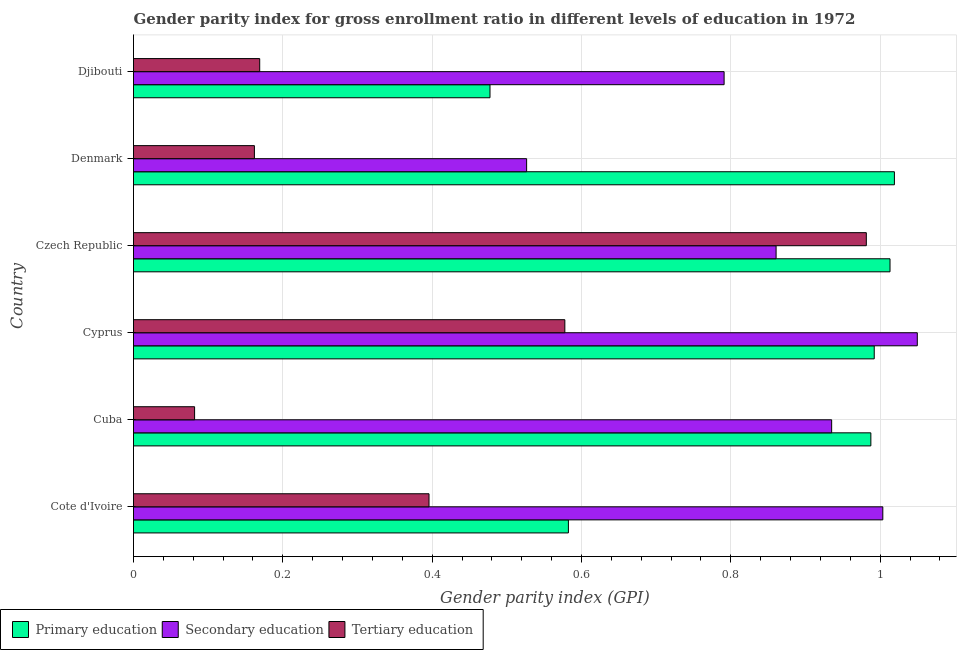How many groups of bars are there?
Your answer should be very brief. 6. Are the number of bars on each tick of the Y-axis equal?
Offer a very short reply. Yes. What is the label of the 4th group of bars from the top?
Your answer should be compact. Cyprus. What is the gender parity index in primary education in Cote d'Ivoire?
Your answer should be compact. 0.58. Across all countries, what is the maximum gender parity index in primary education?
Your answer should be compact. 1.02. Across all countries, what is the minimum gender parity index in secondary education?
Keep it short and to the point. 0.53. In which country was the gender parity index in tertiary education maximum?
Keep it short and to the point. Czech Republic. In which country was the gender parity index in primary education minimum?
Your response must be concise. Djibouti. What is the total gender parity index in primary education in the graph?
Provide a short and direct response. 5.07. What is the difference between the gender parity index in tertiary education in Cyprus and that in Djibouti?
Offer a very short reply. 0.41. What is the difference between the gender parity index in primary education in Cyprus and the gender parity index in secondary education in Cuba?
Keep it short and to the point. 0.06. What is the average gender parity index in secondary education per country?
Provide a succinct answer. 0.86. What is the difference between the gender parity index in secondary education and gender parity index in primary education in Djibouti?
Your response must be concise. 0.31. Is the difference between the gender parity index in primary education in Cyprus and Denmark greater than the difference between the gender parity index in tertiary education in Cyprus and Denmark?
Your answer should be compact. No. What is the difference between the highest and the second highest gender parity index in primary education?
Provide a short and direct response. 0.01. What is the difference between the highest and the lowest gender parity index in primary education?
Your response must be concise. 0.54. Is the sum of the gender parity index in primary education in Czech Republic and Denmark greater than the maximum gender parity index in secondary education across all countries?
Ensure brevity in your answer.  Yes. What does the 2nd bar from the bottom in Djibouti represents?
Offer a very short reply. Secondary education. How many countries are there in the graph?
Keep it short and to the point. 6. What is the difference between two consecutive major ticks on the X-axis?
Provide a short and direct response. 0.2. Does the graph contain grids?
Give a very brief answer. Yes. Where does the legend appear in the graph?
Provide a succinct answer. Bottom left. How are the legend labels stacked?
Give a very brief answer. Horizontal. What is the title of the graph?
Ensure brevity in your answer.  Gender parity index for gross enrollment ratio in different levels of education in 1972. What is the label or title of the X-axis?
Offer a terse response. Gender parity index (GPI). What is the Gender parity index (GPI) in Primary education in Cote d'Ivoire?
Your answer should be compact. 0.58. What is the Gender parity index (GPI) in Secondary education in Cote d'Ivoire?
Give a very brief answer. 1. What is the Gender parity index (GPI) in Tertiary education in Cote d'Ivoire?
Offer a terse response. 0.4. What is the Gender parity index (GPI) in Primary education in Cuba?
Your answer should be very brief. 0.99. What is the Gender parity index (GPI) in Secondary education in Cuba?
Your answer should be very brief. 0.94. What is the Gender parity index (GPI) of Tertiary education in Cuba?
Ensure brevity in your answer.  0.08. What is the Gender parity index (GPI) in Primary education in Cyprus?
Keep it short and to the point. 0.99. What is the Gender parity index (GPI) of Secondary education in Cyprus?
Provide a short and direct response. 1.05. What is the Gender parity index (GPI) of Tertiary education in Cyprus?
Give a very brief answer. 0.58. What is the Gender parity index (GPI) in Primary education in Czech Republic?
Provide a succinct answer. 1.01. What is the Gender parity index (GPI) in Secondary education in Czech Republic?
Give a very brief answer. 0.86. What is the Gender parity index (GPI) of Tertiary education in Czech Republic?
Ensure brevity in your answer.  0.98. What is the Gender parity index (GPI) in Primary education in Denmark?
Your answer should be very brief. 1.02. What is the Gender parity index (GPI) in Secondary education in Denmark?
Provide a short and direct response. 0.53. What is the Gender parity index (GPI) of Tertiary education in Denmark?
Give a very brief answer. 0.16. What is the Gender parity index (GPI) in Primary education in Djibouti?
Your answer should be very brief. 0.48. What is the Gender parity index (GPI) of Secondary education in Djibouti?
Your answer should be very brief. 0.79. What is the Gender parity index (GPI) of Tertiary education in Djibouti?
Your response must be concise. 0.17. Across all countries, what is the maximum Gender parity index (GPI) in Primary education?
Ensure brevity in your answer.  1.02. Across all countries, what is the maximum Gender parity index (GPI) of Secondary education?
Your answer should be very brief. 1.05. Across all countries, what is the maximum Gender parity index (GPI) of Tertiary education?
Keep it short and to the point. 0.98. Across all countries, what is the minimum Gender parity index (GPI) of Primary education?
Provide a short and direct response. 0.48. Across all countries, what is the minimum Gender parity index (GPI) in Secondary education?
Give a very brief answer. 0.53. Across all countries, what is the minimum Gender parity index (GPI) in Tertiary education?
Your answer should be very brief. 0.08. What is the total Gender parity index (GPI) of Primary education in the graph?
Give a very brief answer. 5.07. What is the total Gender parity index (GPI) of Secondary education in the graph?
Keep it short and to the point. 5.17. What is the total Gender parity index (GPI) in Tertiary education in the graph?
Keep it short and to the point. 2.37. What is the difference between the Gender parity index (GPI) of Primary education in Cote d'Ivoire and that in Cuba?
Give a very brief answer. -0.41. What is the difference between the Gender parity index (GPI) in Secondary education in Cote d'Ivoire and that in Cuba?
Give a very brief answer. 0.07. What is the difference between the Gender parity index (GPI) of Tertiary education in Cote d'Ivoire and that in Cuba?
Keep it short and to the point. 0.31. What is the difference between the Gender parity index (GPI) in Primary education in Cote d'Ivoire and that in Cyprus?
Keep it short and to the point. -0.41. What is the difference between the Gender parity index (GPI) in Secondary education in Cote d'Ivoire and that in Cyprus?
Provide a succinct answer. -0.05. What is the difference between the Gender parity index (GPI) of Tertiary education in Cote d'Ivoire and that in Cyprus?
Give a very brief answer. -0.18. What is the difference between the Gender parity index (GPI) in Primary education in Cote d'Ivoire and that in Czech Republic?
Your response must be concise. -0.43. What is the difference between the Gender parity index (GPI) of Secondary education in Cote d'Ivoire and that in Czech Republic?
Keep it short and to the point. 0.14. What is the difference between the Gender parity index (GPI) of Tertiary education in Cote d'Ivoire and that in Czech Republic?
Your answer should be very brief. -0.59. What is the difference between the Gender parity index (GPI) in Primary education in Cote d'Ivoire and that in Denmark?
Provide a short and direct response. -0.44. What is the difference between the Gender parity index (GPI) in Secondary education in Cote d'Ivoire and that in Denmark?
Provide a short and direct response. 0.48. What is the difference between the Gender parity index (GPI) in Tertiary education in Cote d'Ivoire and that in Denmark?
Offer a terse response. 0.23. What is the difference between the Gender parity index (GPI) of Primary education in Cote d'Ivoire and that in Djibouti?
Keep it short and to the point. 0.1. What is the difference between the Gender parity index (GPI) in Secondary education in Cote d'Ivoire and that in Djibouti?
Give a very brief answer. 0.21. What is the difference between the Gender parity index (GPI) in Tertiary education in Cote d'Ivoire and that in Djibouti?
Your response must be concise. 0.23. What is the difference between the Gender parity index (GPI) in Primary education in Cuba and that in Cyprus?
Your answer should be compact. -0. What is the difference between the Gender parity index (GPI) of Secondary education in Cuba and that in Cyprus?
Provide a short and direct response. -0.11. What is the difference between the Gender parity index (GPI) of Tertiary education in Cuba and that in Cyprus?
Provide a succinct answer. -0.5. What is the difference between the Gender parity index (GPI) of Primary education in Cuba and that in Czech Republic?
Keep it short and to the point. -0.03. What is the difference between the Gender parity index (GPI) in Secondary education in Cuba and that in Czech Republic?
Offer a terse response. 0.07. What is the difference between the Gender parity index (GPI) of Tertiary education in Cuba and that in Czech Republic?
Offer a terse response. -0.9. What is the difference between the Gender parity index (GPI) in Primary education in Cuba and that in Denmark?
Your response must be concise. -0.03. What is the difference between the Gender parity index (GPI) in Secondary education in Cuba and that in Denmark?
Your answer should be compact. 0.41. What is the difference between the Gender parity index (GPI) in Tertiary education in Cuba and that in Denmark?
Your answer should be compact. -0.08. What is the difference between the Gender parity index (GPI) of Primary education in Cuba and that in Djibouti?
Make the answer very short. 0.51. What is the difference between the Gender parity index (GPI) in Secondary education in Cuba and that in Djibouti?
Offer a terse response. 0.14. What is the difference between the Gender parity index (GPI) in Tertiary education in Cuba and that in Djibouti?
Provide a succinct answer. -0.09. What is the difference between the Gender parity index (GPI) in Primary education in Cyprus and that in Czech Republic?
Your answer should be very brief. -0.02. What is the difference between the Gender parity index (GPI) in Secondary education in Cyprus and that in Czech Republic?
Offer a terse response. 0.19. What is the difference between the Gender parity index (GPI) of Tertiary education in Cyprus and that in Czech Republic?
Provide a succinct answer. -0.4. What is the difference between the Gender parity index (GPI) of Primary education in Cyprus and that in Denmark?
Offer a very short reply. -0.03. What is the difference between the Gender parity index (GPI) of Secondary education in Cyprus and that in Denmark?
Offer a terse response. 0.52. What is the difference between the Gender parity index (GPI) of Tertiary education in Cyprus and that in Denmark?
Offer a very short reply. 0.42. What is the difference between the Gender parity index (GPI) in Primary education in Cyprus and that in Djibouti?
Provide a succinct answer. 0.51. What is the difference between the Gender parity index (GPI) in Secondary education in Cyprus and that in Djibouti?
Offer a very short reply. 0.26. What is the difference between the Gender parity index (GPI) of Tertiary education in Cyprus and that in Djibouti?
Offer a terse response. 0.41. What is the difference between the Gender parity index (GPI) of Primary education in Czech Republic and that in Denmark?
Make the answer very short. -0.01. What is the difference between the Gender parity index (GPI) in Secondary education in Czech Republic and that in Denmark?
Give a very brief answer. 0.33. What is the difference between the Gender parity index (GPI) in Tertiary education in Czech Republic and that in Denmark?
Keep it short and to the point. 0.82. What is the difference between the Gender parity index (GPI) of Primary education in Czech Republic and that in Djibouti?
Keep it short and to the point. 0.54. What is the difference between the Gender parity index (GPI) of Secondary education in Czech Republic and that in Djibouti?
Keep it short and to the point. 0.07. What is the difference between the Gender parity index (GPI) in Tertiary education in Czech Republic and that in Djibouti?
Provide a succinct answer. 0.81. What is the difference between the Gender parity index (GPI) in Primary education in Denmark and that in Djibouti?
Give a very brief answer. 0.54. What is the difference between the Gender parity index (GPI) of Secondary education in Denmark and that in Djibouti?
Your answer should be very brief. -0.26. What is the difference between the Gender parity index (GPI) in Tertiary education in Denmark and that in Djibouti?
Keep it short and to the point. -0.01. What is the difference between the Gender parity index (GPI) of Primary education in Cote d'Ivoire and the Gender parity index (GPI) of Secondary education in Cuba?
Ensure brevity in your answer.  -0.35. What is the difference between the Gender parity index (GPI) in Primary education in Cote d'Ivoire and the Gender parity index (GPI) in Tertiary education in Cuba?
Provide a succinct answer. 0.5. What is the difference between the Gender parity index (GPI) of Secondary education in Cote d'Ivoire and the Gender parity index (GPI) of Tertiary education in Cuba?
Give a very brief answer. 0.92. What is the difference between the Gender parity index (GPI) in Primary education in Cote d'Ivoire and the Gender parity index (GPI) in Secondary education in Cyprus?
Ensure brevity in your answer.  -0.47. What is the difference between the Gender parity index (GPI) in Primary education in Cote d'Ivoire and the Gender parity index (GPI) in Tertiary education in Cyprus?
Your answer should be very brief. 0. What is the difference between the Gender parity index (GPI) of Secondary education in Cote d'Ivoire and the Gender parity index (GPI) of Tertiary education in Cyprus?
Ensure brevity in your answer.  0.43. What is the difference between the Gender parity index (GPI) in Primary education in Cote d'Ivoire and the Gender parity index (GPI) in Secondary education in Czech Republic?
Your response must be concise. -0.28. What is the difference between the Gender parity index (GPI) of Primary education in Cote d'Ivoire and the Gender parity index (GPI) of Tertiary education in Czech Republic?
Provide a short and direct response. -0.4. What is the difference between the Gender parity index (GPI) of Secondary education in Cote d'Ivoire and the Gender parity index (GPI) of Tertiary education in Czech Republic?
Give a very brief answer. 0.02. What is the difference between the Gender parity index (GPI) in Primary education in Cote d'Ivoire and the Gender parity index (GPI) in Secondary education in Denmark?
Your response must be concise. 0.06. What is the difference between the Gender parity index (GPI) in Primary education in Cote d'Ivoire and the Gender parity index (GPI) in Tertiary education in Denmark?
Offer a very short reply. 0.42. What is the difference between the Gender parity index (GPI) of Secondary education in Cote d'Ivoire and the Gender parity index (GPI) of Tertiary education in Denmark?
Provide a short and direct response. 0.84. What is the difference between the Gender parity index (GPI) in Primary education in Cote d'Ivoire and the Gender parity index (GPI) in Secondary education in Djibouti?
Offer a very short reply. -0.21. What is the difference between the Gender parity index (GPI) in Primary education in Cote d'Ivoire and the Gender parity index (GPI) in Tertiary education in Djibouti?
Keep it short and to the point. 0.41. What is the difference between the Gender parity index (GPI) of Secondary education in Cote d'Ivoire and the Gender parity index (GPI) of Tertiary education in Djibouti?
Your answer should be very brief. 0.83. What is the difference between the Gender parity index (GPI) in Primary education in Cuba and the Gender parity index (GPI) in Secondary education in Cyprus?
Make the answer very short. -0.06. What is the difference between the Gender parity index (GPI) in Primary education in Cuba and the Gender parity index (GPI) in Tertiary education in Cyprus?
Your answer should be compact. 0.41. What is the difference between the Gender parity index (GPI) in Secondary education in Cuba and the Gender parity index (GPI) in Tertiary education in Cyprus?
Give a very brief answer. 0.36. What is the difference between the Gender parity index (GPI) of Primary education in Cuba and the Gender parity index (GPI) of Secondary education in Czech Republic?
Provide a succinct answer. 0.13. What is the difference between the Gender parity index (GPI) of Primary education in Cuba and the Gender parity index (GPI) of Tertiary education in Czech Republic?
Provide a short and direct response. 0.01. What is the difference between the Gender parity index (GPI) of Secondary education in Cuba and the Gender parity index (GPI) of Tertiary education in Czech Republic?
Provide a succinct answer. -0.05. What is the difference between the Gender parity index (GPI) of Primary education in Cuba and the Gender parity index (GPI) of Secondary education in Denmark?
Your answer should be compact. 0.46. What is the difference between the Gender parity index (GPI) in Primary education in Cuba and the Gender parity index (GPI) in Tertiary education in Denmark?
Offer a terse response. 0.83. What is the difference between the Gender parity index (GPI) in Secondary education in Cuba and the Gender parity index (GPI) in Tertiary education in Denmark?
Provide a succinct answer. 0.77. What is the difference between the Gender parity index (GPI) of Primary education in Cuba and the Gender parity index (GPI) of Secondary education in Djibouti?
Provide a succinct answer. 0.2. What is the difference between the Gender parity index (GPI) in Primary education in Cuba and the Gender parity index (GPI) in Tertiary education in Djibouti?
Offer a terse response. 0.82. What is the difference between the Gender parity index (GPI) of Secondary education in Cuba and the Gender parity index (GPI) of Tertiary education in Djibouti?
Offer a terse response. 0.77. What is the difference between the Gender parity index (GPI) of Primary education in Cyprus and the Gender parity index (GPI) of Secondary education in Czech Republic?
Give a very brief answer. 0.13. What is the difference between the Gender parity index (GPI) of Primary education in Cyprus and the Gender parity index (GPI) of Tertiary education in Czech Republic?
Offer a very short reply. 0.01. What is the difference between the Gender parity index (GPI) of Secondary education in Cyprus and the Gender parity index (GPI) of Tertiary education in Czech Republic?
Your response must be concise. 0.07. What is the difference between the Gender parity index (GPI) of Primary education in Cyprus and the Gender parity index (GPI) of Secondary education in Denmark?
Offer a terse response. 0.47. What is the difference between the Gender parity index (GPI) in Primary education in Cyprus and the Gender parity index (GPI) in Tertiary education in Denmark?
Provide a short and direct response. 0.83. What is the difference between the Gender parity index (GPI) of Secondary education in Cyprus and the Gender parity index (GPI) of Tertiary education in Denmark?
Provide a succinct answer. 0.89. What is the difference between the Gender parity index (GPI) in Primary education in Cyprus and the Gender parity index (GPI) in Secondary education in Djibouti?
Offer a very short reply. 0.2. What is the difference between the Gender parity index (GPI) of Primary education in Cyprus and the Gender parity index (GPI) of Tertiary education in Djibouti?
Keep it short and to the point. 0.82. What is the difference between the Gender parity index (GPI) in Secondary education in Cyprus and the Gender parity index (GPI) in Tertiary education in Djibouti?
Offer a very short reply. 0.88. What is the difference between the Gender parity index (GPI) of Primary education in Czech Republic and the Gender parity index (GPI) of Secondary education in Denmark?
Provide a short and direct response. 0.49. What is the difference between the Gender parity index (GPI) in Primary education in Czech Republic and the Gender parity index (GPI) in Tertiary education in Denmark?
Provide a succinct answer. 0.85. What is the difference between the Gender parity index (GPI) in Secondary education in Czech Republic and the Gender parity index (GPI) in Tertiary education in Denmark?
Offer a very short reply. 0.7. What is the difference between the Gender parity index (GPI) of Primary education in Czech Republic and the Gender parity index (GPI) of Secondary education in Djibouti?
Offer a very short reply. 0.22. What is the difference between the Gender parity index (GPI) in Primary education in Czech Republic and the Gender parity index (GPI) in Tertiary education in Djibouti?
Give a very brief answer. 0.84. What is the difference between the Gender parity index (GPI) of Secondary education in Czech Republic and the Gender parity index (GPI) of Tertiary education in Djibouti?
Your answer should be compact. 0.69. What is the difference between the Gender parity index (GPI) in Primary education in Denmark and the Gender parity index (GPI) in Secondary education in Djibouti?
Keep it short and to the point. 0.23. What is the difference between the Gender parity index (GPI) in Primary education in Denmark and the Gender parity index (GPI) in Tertiary education in Djibouti?
Provide a succinct answer. 0.85. What is the difference between the Gender parity index (GPI) in Secondary education in Denmark and the Gender parity index (GPI) in Tertiary education in Djibouti?
Make the answer very short. 0.36. What is the average Gender parity index (GPI) of Primary education per country?
Give a very brief answer. 0.85. What is the average Gender parity index (GPI) in Secondary education per country?
Your answer should be compact. 0.86. What is the average Gender parity index (GPI) in Tertiary education per country?
Your answer should be very brief. 0.39. What is the difference between the Gender parity index (GPI) in Primary education and Gender parity index (GPI) in Secondary education in Cote d'Ivoire?
Your answer should be very brief. -0.42. What is the difference between the Gender parity index (GPI) in Primary education and Gender parity index (GPI) in Tertiary education in Cote d'Ivoire?
Provide a short and direct response. 0.19. What is the difference between the Gender parity index (GPI) of Secondary education and Gender parity index (GPI) of Tertiary education in Cote d'Ivoire?
Provide a succinct answer. 0.61. What is the difference between the Gender parity index (GPI) in Primary education and Gender parity index (GPI) in Secondary education in Cuba?
Your answer should be very brief. 0.05. What is the difference between the Gender parity index (GPI) in Primary education and Gender parity index (GPI) in Tertiary education in Cuba?
Provide a short and direct response. 0.91. What is the difference between the Gender parity index (GPI) in Secondary education and Gender parity index (GPI) in Tertiary education in Cuba?
Offer a terse response. 0.85. What is the difference between the Gender parity index (GPI) of Primary education and Gender parity index (GPI) of Secondary education in Cyprus?
Keep it short and to the point. -0.06. What is the difference between the Gender parity index (GPI) in Primary education and Gender parity index (GPI) in Tertiary education in Cyprus?
Offer a very short reply. 0.41. What is the difference between the Gender parity index (GPI) of Secondary education and Gender parity index (GPI) of Tertiary education in Cyprus?
Provide a succinct answer. 0.47. What is the difference between the Gender parity index (GPI) of Primary education and Gender parity index (GPI) of Secondary education in Czech Republic?
Make the answer very short. 0.15. What is the difference between the Gender parity index (GPI) of Primary education and Gender parity index (GPI) of Tertiary education in Czech Republic?
Offer a terse response. 0.03. What is the difference between the Gender parity index (GPI) in Secondary education and Gender parity index (GPI) in Tertiary education in Czech Republic?
Ensure brevity in your answer.  -0.12. What is the difference between the Gender parity index (GPI) of Primary education and Gender parity index (GPI) of Secondary education in Denmark?
Your answer should be compact. 0.49. What is the difference between the Gender parity index (GPI) of Secondary education and Gender parity index (GPI) of Tertiary education in Denmark?
Ensure brevity in your answer.  0.36. What is the difference between the Gender parity index (GPI) of Primary education and Gender parity index (GPI) of Secondary education in Djibouti?
Keep it short and to the point. -0.31. What is the difference between the Gender parity index (GPI) in Primary education and Gender parity index (GPI) in Tertiary education in Djibouti?
Offer a terse response. 0.31. What is the difference between the Gender parity index (GPI) in Secondary education and Gender parity index (GPI) in Tertiary education in Djibouti?
Make the answer very short. 0.62. What is the ratio of the Gender parity index (GPI) in Primary education in Cote d'Ivoire to that in Cuba?
Give a very brief answer. 0.59. What is the ratio of the Gender parity index (GPI) in Secondary education in Cote d'Ivoire to that in Cuba?
Keep it short and to the point. 1.07. What is the ratio of the Gender parity index (GPI) of Tertiary education in Cote d'Ivoire to that in Cuba?
Keep it short and to the point. 4.84. What is the ratio of the Gender parity index (GPI) in Primary education in Cote d'Ivoire to that in Cyprus?
Your answer should be very brief. 0.59. What is the ratio of the Gender parity index (GPI) in Secondary education in Cote d'Ivoire to that in Cyprus?
Provide a short and direct response. 0.96. What is the ratio of the Gender parity index (GPI) in Tertiary education in Cote d'Ivoire to that in Cyprus?
Make the answer very short. 0.69. What is the ratio of the Gender parity index (GPI) of Primary education in Cote d'Ivoire to that in Czech Republic?
Offer a terse response. 0.57. What is the ratio of the Gender parity index (GPI) in Secondary education in Cote d'Ivoire to that in Czech Republic?
Your response must be concise. 1.17. What is the ratio of the Gender parity index (GPI) in Tertiary education in Cote d'Ivoire to that in Czech Republic?
Your response must be concise. 0.4. What is the ratio of the Gender parity index (GPI) of Primary education in Cote d'Ivoire to that in Denmark?
Offer a terse response. 0.57. What is the ratio of the Gender parity index (GPI) of Secondary education in Cote d'Ivoire to that in Denmark?
Give a very brief answer. 1.91. What is the ratio of the Gender parity index (GPI) of Tertiary education in Cote d'Ivoire to that in Denmark?
Provide a succinct answer. 2.44. What is the ratio of the Gender parity index (GPI) of Primary education in Cote d'Ivoire to that in Djibouti?
Provide a short and direct response. 1.22. What is the ratio of the Gender parity index (GPI) of Secondary education in Cote d'Ivoire to that in Djibouti?
Offer a very short reply. 1.27. What is the ratio of the Gender parity index (GPI) of Tertiary education in Cote d'Ivoire to that in Djibouti?
Your answer should be compact. 2.34. What is the ratio of the Gender parity index (GPI) of Secondary education in Cuba to that in Cyprus?
Your answer should be compact. 0.89. What is the ratio of the Gender parity index (GPI) in Tertiary education in Cuba to that in Cyprus?
Provide a succinct answer. 0.14. What is the ratio of the Gender parity index (GPI) in Primary education in Cuba to that in Czech Republic?
Your answer should be compact. 0.97. What is the ratio of the Gender parity index (GPI) in Secondary education in Cuba to that in Czech Republic?
Keep it short and to the point. 1.09. What is the ratio of the Gender parity index (GPI) in Tertiary education in Cuba to that in Czech Republic?
Offer a terse response. 0.08. What is the ratio of the Gender parity index (GPI) of Primary education in Cuba to that in Denmark?
Provide a short and direct response. 0.97. What is the ratio of the Gender parity index (GPI) of Secondary education in Cuba to that in Denmark?
Keep it short and to the point. 1.78. What is the ratio of the Gender parity index (GPI) of Tertiary education in Cuba to that in Denmark?
Make the answer very short. 0.51. What is the ratio of the Gender parity index (GPI) of Primary education in Cuba to that in Djibouti?
Keep it short and to the point. 2.07. What is the ratio of the Gender parity index (GPI) of Secondary education in Cuba to that in Djibouti?
Provide a succinct answer. 1.18. What is the ratio of the Gender parity index (GPI) in Tertiary education in Cuba to that in Djibouti?
Make the answer very short. 0.48. What is the ratio of the Gender parity index (GPI) of Primary education in Cyprus to that in Czech Republic?
Provide a succinct answer. 0.98. What is the ratio of the Gender parity index (GPI) in Secondary education in Cyprus to that in Czech Republic?
Provide a short and direct response. 1.22. What is the ratio of the Gender parity index (GPI) of Tertiary education in Cyprus to that in Czech Republic?
Your answer should be very brief. 0.59. What is the ratio of the Gender parity index (GPI) of Primary education in Cyprus to that in Denmark?
Keep it short and to the point. 0.97. What is the ratio of the Gender parity index (GPI) of Secondary education in Cyprus to that in Denmark?
Provide a short and direct response. 1.99. What is the ratio of the Gender parity index (GPI) of Tertiary education in Cyprus to that in Denmark?
Keep it short and to the point. 3.57. What is the ratio of the Gender parity index (GPI) in Primary education in Cyprus to that in Djibouti?
Your answer should be very brief. 2.08. What is the ratio of the Gender parity index (GPI) in Secondary education in Cyprus to that in Djibouti?
Your answer should be very brief. 1.33. What is the ratio of the Gender parity index (GPI) of Tertiary education in Cyprus to that in Djibouti?
Your answer should be very brief. 3.42. What is the ratio of the Gender parity index (GPI) of Primary education in Czech Republic to that in Denmark?
Provide a succinct answer. 0.99. What is the ratio of the Gender parity index (GPI) of Secondary education in Czech Republic to that in Denmark?
Make the answer very short. 1.63. What is the ratio of the Gender parity index (GPI) in Tertiary education in Czech Republic to that in Denmark?
Provide a short and direct response. 6.06. What is the ratio of the Gender parity index (GPI) in Primary education in Czech Republic to that in Djibouti?
Offer a very short reply. 2.12. What is the ratio of the Gender parity index (GPI) in Secondary education in Czech Republic to that in Djibouti?
Give a very brief answer. 1.09. What is the ratio of the Gender parity index (GPI) in Tertiary education in Czech Republic to that in Djibouti?
Offer a terse response. 5.81. What is the ratio of the Gender parity index (GPI) in Primary education in Denmark to that in Djibouti?
Ensure brevity in your answer.  2.13. What is the ratio of the Gender parity index (GPI) in Secondary education in Denmark to that in Djibouti?
Provide a succinct answer. 0.67. What is the ratio of the Gender parity index (GPI) of Tertiary education in Denmark to that in Djibouti?
Offer a terse response. 0.96. What is the difference between the highest and the second highest Gender parity index (GPI) of Primary education?
Give a very brief answer. 0.01. What is the difference between the highest and the second highest Gender parity index (GPI) of Secondary education?
Keep it short and to the point. 0.05. What is the difference between the highest and the second highest Gender parity index (GPI) in Tertiary education?
Offer a terse response. 0.4. What is the difference between the highest and the lowest Gender parity index (GPI) in Primary education?
Offer a very short reply. 0.54. What is the difference between the highest and the lowest Gender parity index (GPI) in Secondary education?
Keep it short and to the point. 0.52. What is the difference between the highest and the lowest Gender parity index (GPI) in Tertiary education?
Your answer should be compact. 0.9. 